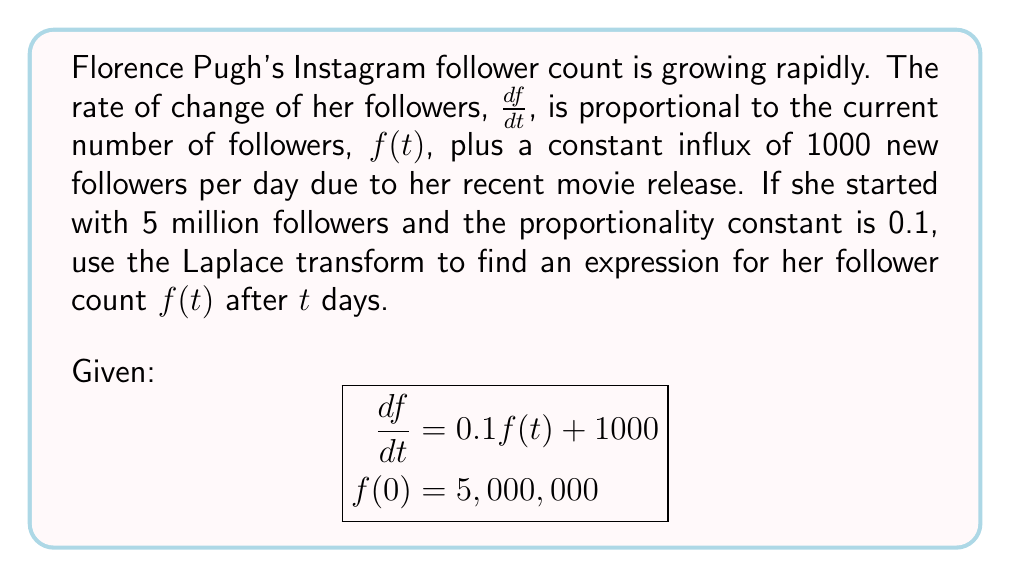What is the answer to this math problem? Let's solve this step-by-step using Laplace transforms:

1) Take the Laplace transform of both sides of the differential equation:
   $$\mathcal{L}\left\{\frac{df}{dt}\right\} = \mathcal{L}\{0.1f(t) + 1000\}$$

2) Using Laplace transform properties:
   $$sF(s) - f(0) = 0.1F(s) + \frac{1000}{s}$$

3) Substitute the initial condition $f(0) = 5,000,000$:
   $$sF(s) - 5,000,000 = 0.1F(s) + \frac{1000}{s}$$

4) Rearrange terms:
   $$(s - 0.1)F(s) = 5,000,000 + \frac{1000}{s}$$

5) Solve for $F(s)$:
   $$F(s) = \frac{5,000,000}{s - 0.1} + \frac{1000}{s(s - 0.1)}$$

6) Decompose into partial fractions:
   $$F(s) = \frac{5,000,000}{s - 0.1} + \frac{10,000}{s} - \frac{10,000}{s - 0.1}$$

7) Take the inverse Laplace transform:
   $$f(t) = 5,000,000e^{0.1t} + 10,000 - 10,000e^{0.1t}$$

8) Simplify:
   $$f(t) = 4,990,000e^{0.1t} + 10,000$$

This expression represents Florence Pugh's follower count after $t$ days.
Answer: $f(t) = 4,990,000e^{0.1t} + 10,000$ 